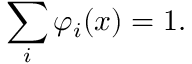Convert formula to latex. <formula><loc_0><loc_0><loc_500><loc_500>\sum _ { i } \varphi _ { i } ( x ) = 1 .</formula> 